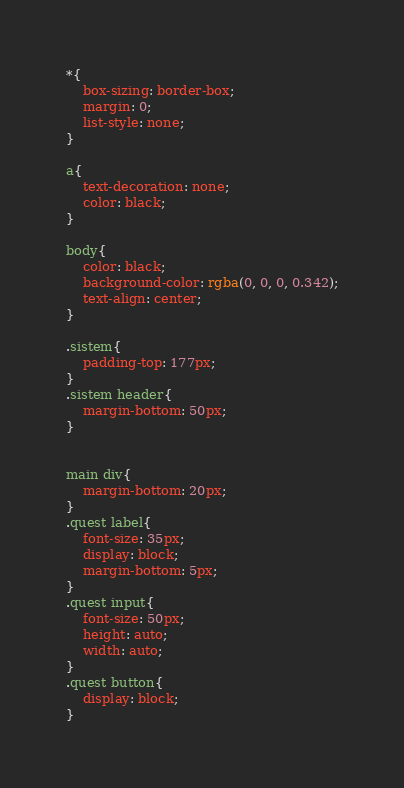<code> <loc_0><loc_0><loc_500><loc_500><_CSS_>*{
    box-sizing: border-box;
    margin: 0;
    list-style: none;
}

a{
    text-decoration: none;
    color: black;
}

body{
    color: black;
    background-color: rgba(0, 0, 0, 0.342);
    text-align: center;
}

.sistem{
    padding-top: 177px;
}
.sistem header{
    margin-bottom: 50px;
}


main div{
    margin-bottom: 20px;
}
.quest label{
    font-size: 35px;
    display: block;
    margin-bottom: 5px;
}
.quest input{
    font-size: 50px;
    height: auto;
    width: auto;
}
.quest button{
    display: block;
}

</code> 